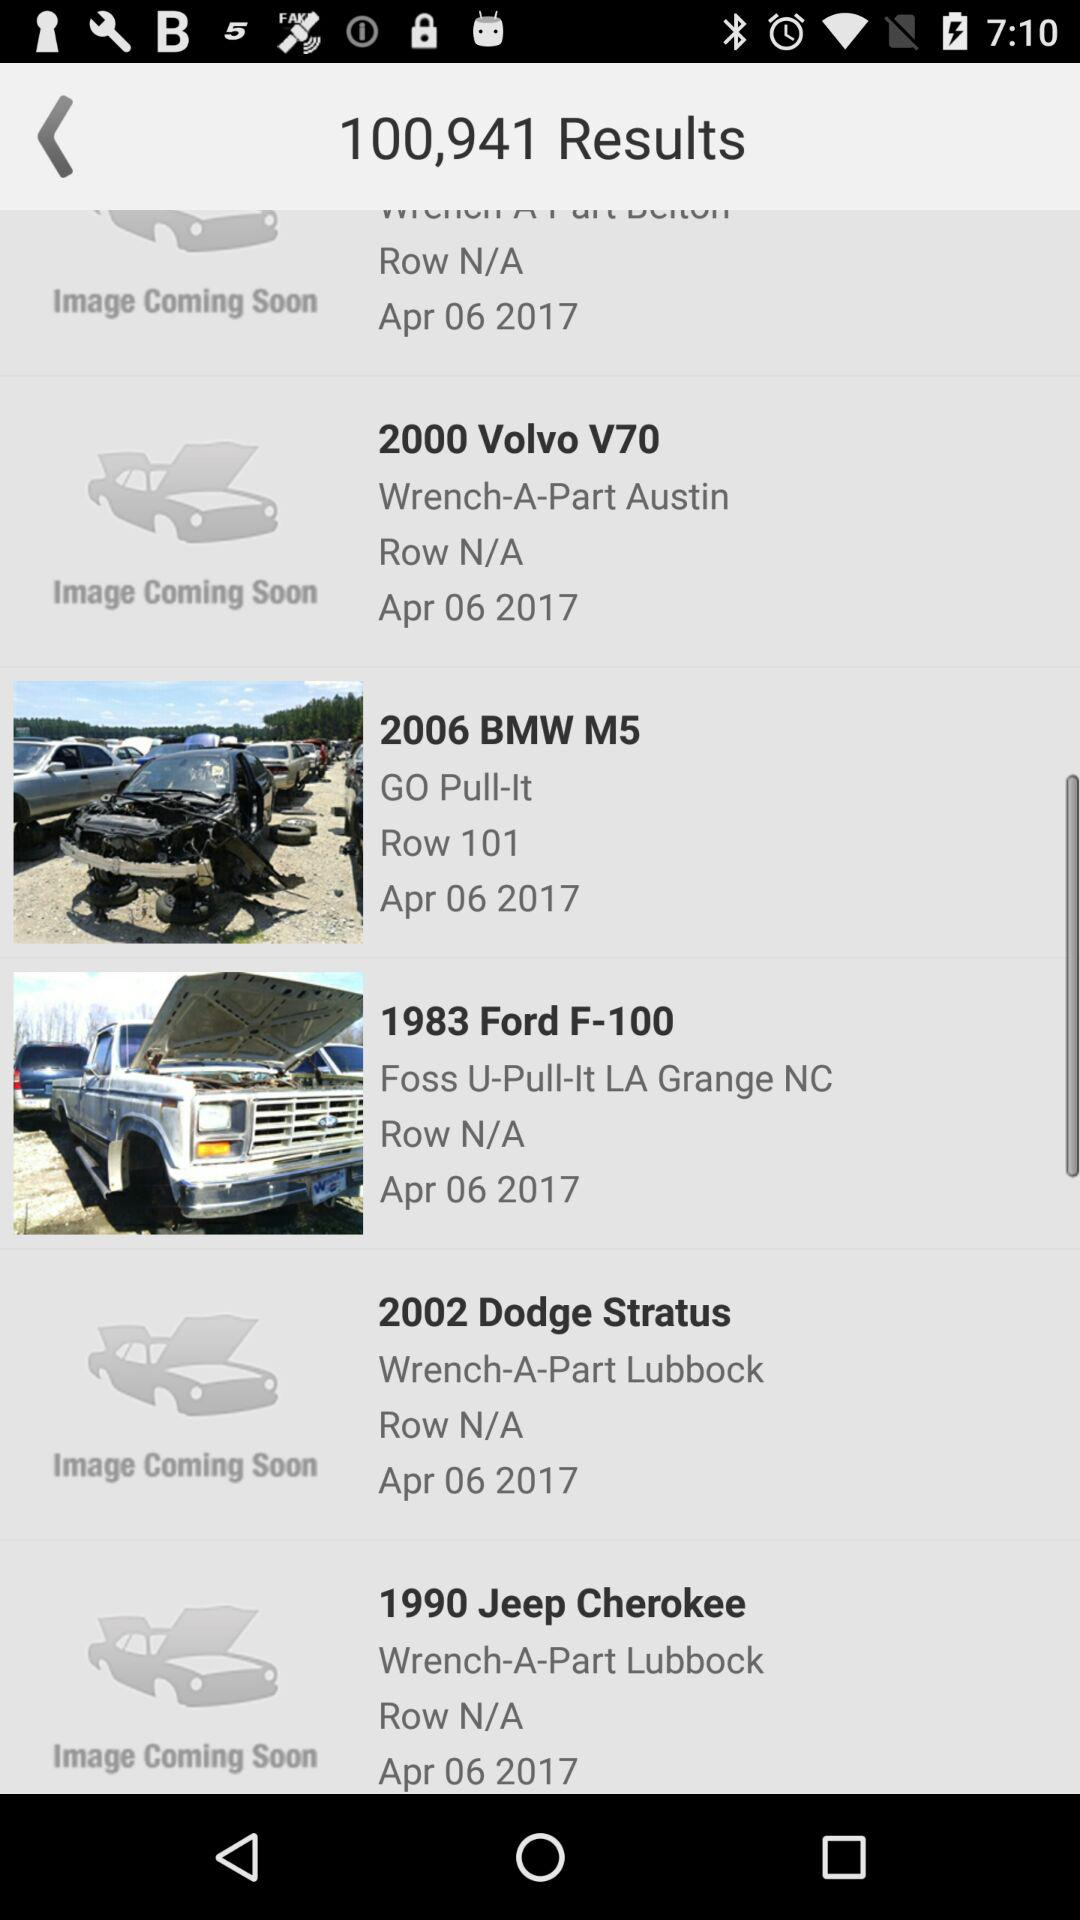How many results are there in total?
Answer the question using a single word or phrase. 100,941 